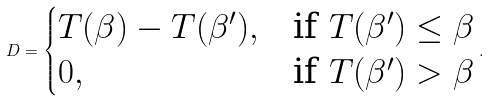Convert formula to latex. <formula><loc_0><loc_0><loc_500><loc_500>D = \begin{cases} T ( \beta ) - T ( \beta ^ { \prime } ) , & \text {if } T ( \beta ^ { \prime } ) \leq \beta \\ 0 , & \text {if } T ( \beta ^ { \prime } ) > \beta \end{cases} .</formula> 